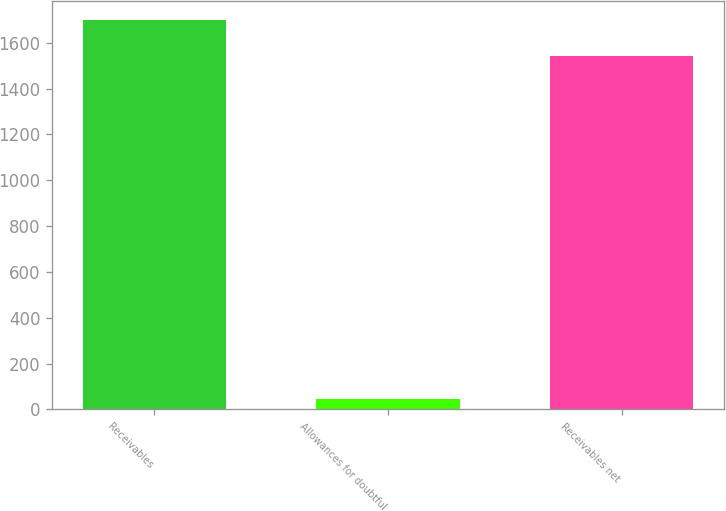Convert chart to OTSL. <chart><loc_0><loc_0><loc_500><loc_500><bar_chart><fcel>Receivables<fcel>Allowances for doubtful<fcel>Receivables net<nl><fcel>1698.4<fcel>46<fcel>1544<nl></chart> 